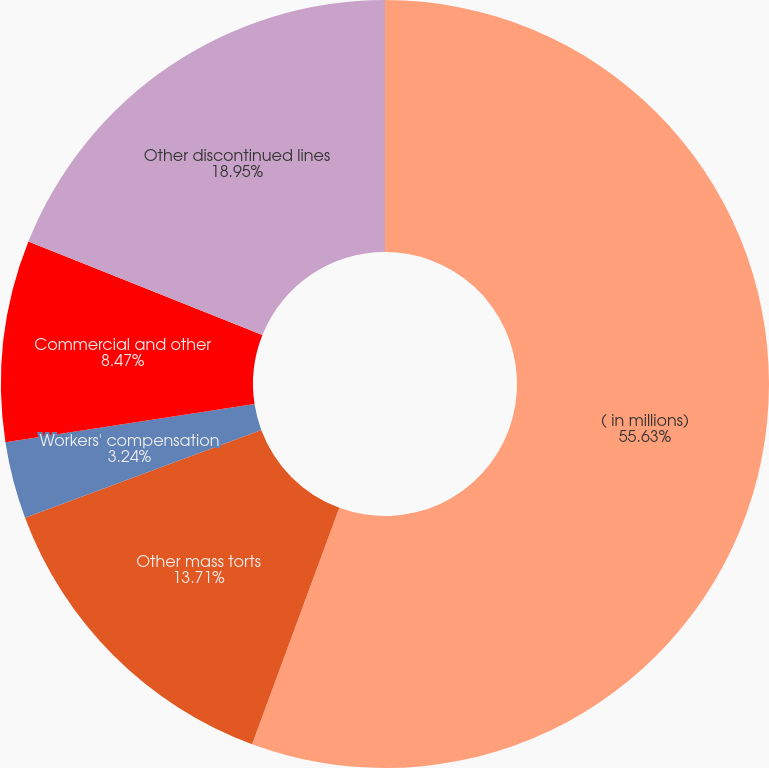Convert chart. <chart><loc_0><loc_0><loc_500><loc_500><pie_chart><fcel>( in millions)<fcel>Other mass torts<fcel>Workers' compensation<fcel>Commercial and other<fcel>Other discontinued lines<nl><fcel>55.62%<fcel>13.71%<fcel>3.24%<fcel>8.47%<fcel>18.95%<nl></chart> 